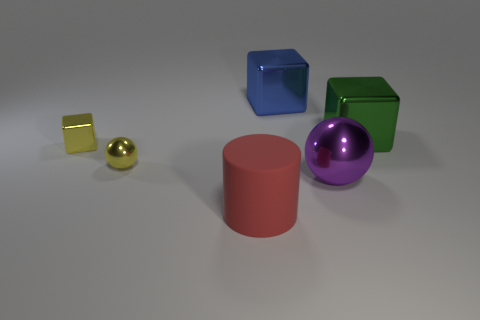Subtract all big metal cubes. How many cubes are left? 1 Add 4 red cylinders. How many objects exist? 10 Subtract all green cubes. How many cubes are left? 2 Subtract all spheres. How many objects are left? 4 Subtract 1 spheres. How many spheres are left? 1 Subtract all small metal balls. Subtract all tiny shiny balls. How many objects are left? 4 Add 2 tiny yellow cubes. How many tiny yellow cubes are left? 3 Add 2 big cyan matte cylinders. How many big cyan matte cylinders exist? 2 Subtract 0 blue cylinders. How many objects are left? 6 Subtract all purple blocks. Subtract all cyan cylinders. How many blocks are left? 3 